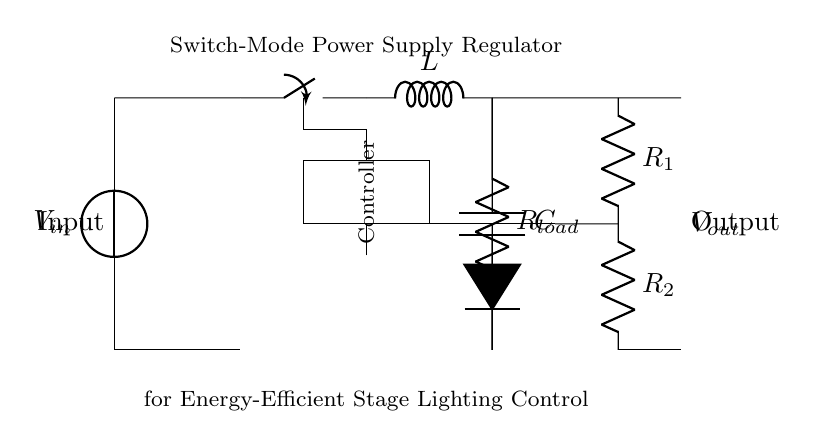What is the input voltage? The input voltage is labeled as Vin in the diagram, which typically represents the voltage supplied to the circuit.
Answer: Vin What component is used for energy storage? The component for energy storage is a capacitor, denoted by C in the circuit. It stores energy when the switch is closed and releases it when the switch is open.
Answer: Capacitor What does the switch control? The switch controls the flow of current in the circuit by opening or closing the path, effectively regulating the power supplied to the load.
Answer: Current flow How many resistors are in the feedback loop? There are two resistors, R1 and R2, which form a voltage divider for feedback to the controller. This configuration helps maintain the output voltage at a desired level.
Answer: Two What is the purpose of the diode in this circuit? The diode allows current to flow in one direction only, providing protection against reverse voltage that could damage the circuit components, especially the switch and capacitor.
Answer: Protection against reverse voltage What type of regulator is shown in the diagram? The circuit illustrates a switch-mode power supply regulator, distinguished by its use of a switch instead of a linear regulator. It is designed for efficient power conversion.
Answer: Switch-mode power supply regulator Where does the output voltage appear in the circuit? The output voltage, labeled Vout, appears at the terminal where the load is connected, indicating the voltage delivered to the load from the output of the regulator circuit.
Answer: At the load terminal 